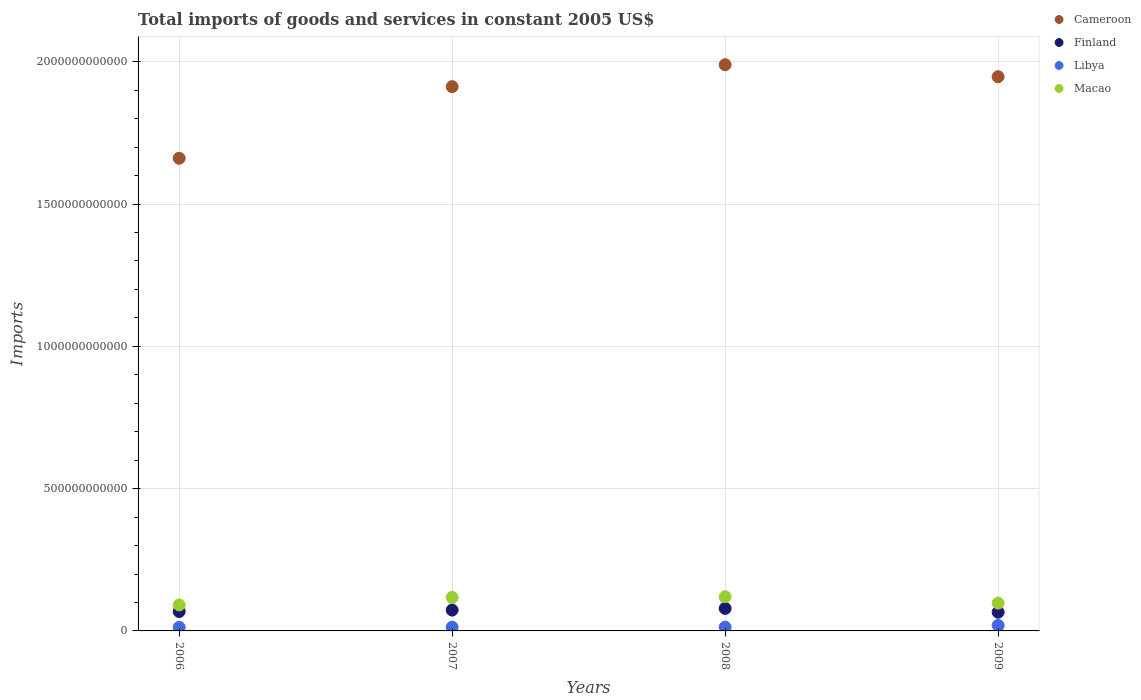What is the total imports of goods and services in Macao in 2008?
Your answer should be very brief. 1.20e+11. Across all years, what is the maximum total imports of goods and services in Libya?
Offer a very short reply. 1.93e+1. Across all years, what is the minimum total imports of goods and services in Macao?
Your answer should be very brief. 9.13e+1. In which year was the total imports of goods and services in Libya minimum?
Your answer should be compact. 2006. What is the total total imports of goods and services in Libya in the graph?
Ensure brevity in your answer.  5.80e+1. What is the difference between the total imports of goods and services in Libya in 2007 and that in 2008?
Give a very brief answer. -7.44e+07. What is the difference between the total imports of goods and services in Cameroon in 2006 and the total imports of goods and services in Finland in 2007?
Provide a short and direct response. 1.59e+12. What is the average total imports of goods and services in Libya per year?
Offer a terse response. 1.45e+1. In the year 2008, what is the difference between the total imports of goods and services in Finland and total imports of goods and services in Macao?
Provide a succinct answer. -4.11e+1. In how many years, is the total imports of goods and services in Finland greater than 800000000000 US$?
Your answer should be compact. 0. What is the ratio of the total imports of goods and services in Macao in 2006 to that in 2007?
Keep it short and to the point. 0.78. Is the total imports of goods and services in Finland in 2006 less than that in 2008?
Make the answer very short. Yes. What is the difference between the highest and the second highest total imports of goods and services in Finland?
Provide a short and direct response. 5.80e+09. What is the difference between the highest and the lowest total imports of goods and services in Libya?
Your response must be concise. 6.82e+09. In how many years, is the total imports of goods and services in Cameroon greater than the average total imports of goods and services in Cameroon taken over all years?
Keep it short and to the point. 3. Is it the case that in every year, the sum of the total imports of goods and services in Macao and total imports of goods and services in Cameroon  is greater than the sum of total imports of goods and services in Finland and total imports of goods and services in Libya?
Make the answer very short. Yes. Is the total imports of goods and services in Finland strictly greater than the total imports of goods and services in Cameroon over the years?
Provide a succinct answer. No. Is the total imports of goods and services in Libya strictly less than the total imports of goods and services in Finland over the years?
Ensure brevity in your answer.  Yes. How many years are there in the graph?
Provide a succinct answer. 4. What is the difference between two consecutive major ticks on the Y-axis?
Provide a short and direct response. 5.00e+11. Are the values on the major ticks of Y-axis written in scientific E-notation?
Your answer should be compact. No. Does the graph contain any zero values?
Make the answer very short. No. Where does the legend appear in the graph?
Your response must be concise. Top right. How many legend labels are there?
Make the answer very short. 4. What is the title of the graph?
Provide a succinct answer. Total imports of goods and services in constant 2005 US$. Does "Djibouti" appear as one of the legend labels in the graph?
Provide a short and direct response. No. What is the label or title of the Y-axis?
Your response must be concise. Imports. What is the Imports in Cameroon in 2006?
Ensure brevity in your answer.  1.66e+12. What is the Imports in Finland in 2006?
Your response must be concise. 6.82e+1. What is the Imports of Libya in 2006?
Your answer should be compact. 1.25e+1. What is the Imports in Macao in 2006?
Keep it short and to the point. 9.13e+1. What is the Imports in Cameroon in 2007?
Provide a succinct answer. 1.91e+12. What is the Imports in Finland in 2007?
Offer a very short reply. 7.32e+1. What is the Imports in Libya in 2007?
Keep it short and to the point. 1.31e+1. What is the Imports in Macao in 2007?
Ensure brevity in your answer.  1.18e+11. What is the Imports in Cameroon in 2008?
Provide a short and direct response. 1.99e+12. What is the Imports in Finland in 2008?
Your answer should be very brief. 7.90e+1. What is the Imports in Libya in 2008?
Provide a short and direct response. 1.32e+1. What is the Imports of Macao in 2008?
Provide a succinct answer. 1.20e+11. What is the Imports of Cameroon in 2009?
Make the answer very short. 1.95e+12. What is the Imports of Finland in 2009?
Give a very brief answer. 6.57e+1. What is the Imports of Libya in 2009?
Keep it short and to the point. 1.93e+1. What is the Imports of Macao in 2009?
Ensure brevity in your answer.  9.76e+1. Across all years, what is the maximum Imports in Cameroon?
Your response must be concise. 1.99e+12. Across all years, what is the maximum Imports in Finland?
Provide a succinct answer. 7.90e+1. Across all years, what is the maximum Imports of Libya?
Keep it short and to the point. 1.93e+1. Across all years, what is the maximum Imports of Macao?
Your response must be concise. 1.20e+11. Across all years, what is the minimum Imports in Cameroon?
Ensure brevity in your answer.  1.66e+12. Across all years, what is the minimum Imports of Finland?
Offer a terse response. 6.57e+1. Across all years, what is the minimum Imports in Libya?
Keep it short and to the point. 1.25e+1. Across all years, what is the minimum Imports of Macao?
Make the answer very short. 9.13e+1. What is the total Imports in Cameroon in the graph?
Provide a short and direct response. 7.51e+12. What is the total Imports in Finland in the graph?
Offer a very short reply. 2.86e+11. What is the total Imports of Libya in the graph?
Make the answer very short. 5.80e+1. What is the total Imports of Macao in the graph?
Offer a very short reply. 4.27e+11. What is the difference between the Imports of Cameroon in 2006 and that in 2007?
Keep it short and to the point. -2.52e+11. What is the difference between the Imports in Finland in 2006 and that in 2007?
Make the answer very short. -5.05e+09. What is the difference between the Imports in Libya in 2006 and that in 2007?
Offer a very short reply. -6.30e+08. What is the difference between the Imports in Macao in 2006 and that in 2007?
Ensure brevity in your answer.  -2.65e+1. What is the difference between the Imports in Cameroon in 2006 and that in 2008?
Keep it short and to the point. -3.29e+11. What is the difference between the Imports in Finland in 2006 and that in 2008?
Provide a short and direct response. -1.09e+1. What is the difference between the Imports in Libya in 2006 and that in 2008?
Make the answer very short. -7.05e+08. What is the difference between the Imports of Macao in 2006 and that in 2008?
Your answer should be compact. -2.89e+1. What is the difference between the Imports in Cameroon in 2006 and that in 2009?
Make the answer very short. -2.87e+11. What is the difference between the Imports of Finland in 2006 and that in 2009?
Your response must be concise. 2.47e+09. What is the difference between the Imports in Libya in 2006 and that in 2009?
Your answer should be compact. -6.82e+09. What is the difference between the Imports in Macao in 2006 and that in 2009?
Your answer should be compact. -6.38e+09. What is the difference between the Imports of Cameroon in 2007 and that in 2008?
Give a very brief answer. -7.72e+1. What is the difference between the Imports of Finland in 2007 and that in 2008?
Your answer should be very brief. -5.80e+09. What is the difference between the Imports of Libya in 2007 and that in 2008?
Your answer should be very brief. -7.44e+07. What is the difference between the Imports of Macao in 2007 and that in 2008?
Ensure brevity in your answer.  -2.39e+09. What is the difference between the Imports in Cameroon in 2007 and that in 2009?
Your answer should be very brief. -3.50e+1. What is the difference between the Imports in Finland in 2007 and that in 2009?
Offer a very short reply. 7.52e+09. What is the difference between the Imports in Libya in 2007 and that in 2009?
Your response must be concise. -6.19e+09. What is the difference between the Imports in Macao in 2007 and that in 2009?
Offer a terse response. 2.01e+1. What is the difference between the Imports in Cameroon in 2008 and that in 2009?
Make the answer very short. 4.22e+1. What is the difference between the Imports of Finland in 2008 and that in 2009?
Keep it short and to the point. 1.33e+1. What is the difference between the Imports in Libya in 2008 and that in 2009?
Keep it short and to the point. -6.12e+09. What is the difference between the Imports of Macao in 2008 and that in 2009?
Give a very brief answer. 2.25e+1. What is the difference between the Imports of Cameroon in 2006 and the Imports of Finland in 2007?
Make the answer very short. 1.59e+12. What is the difference between the Imports of Cameroon in 2006 and the Imports of Libya in 2007?
Your answer should be very brief. 1.65e+12. What is the difference between the Imports of Cameroon in 2006 and the Imports of Macao in 2007?
Your answer should be compact. 1.54e+12. What is the difference between the Imports in Finland in 2006 and the Imports in Libya in 2007?
Your response must be concise. 5.51e+1. What is the difference between the Imports in Finland in 2006 and the Imports in Macao in 2007?
Provide a succinct answer. -4.95e+1. What is the difference between the Imports in Libya in 2006 and the Imports in Macao in 2007?
Ensure brevity in your answer.  -1.05e+11. What is the difference between the Imports of Cameroon in 2006 and the Imports of Finland in 2008?
Your response must be concise. 1.58e+12. What is the difference between the Imports in Cameroon in 2006 and the Imports in Libya in 2008?
Ensure brevity in your answer.  1.65e+12. What is the difference between the Imports in Cameroon in 2006 and the Imports in Macao in 2008?
Give a very brief answer. 1.54e+12. What is the difference between the Imports in Finland in 2006 and the Imports in Libya in 2008?
Your answer should be compact. 5.50e+1. What is the difference between the Imports in Finland in 2006 and the Imports in Macao in 2008?
Your response must be concise. -5.19e+1. What is the difference between the Imports in Libya in 2006 and the Imports in Macao in 2008?
Provide a short and direct response. -1.08e+11. What is the difference between the Imports in Cameroon in 2006 and the Imports in Finland in 2009?
Your answer should be very brief. 1.60e+12. What is the difference between the Imports in Cameroon in 2006 and the Imports in Libya in 2009?
Your answer should be very brief. 1.64e+12. What is the difference between the Imports in Cameroon in 2006 and the Imports in Macao in 2009?
Ensure brevity in your answer.  1.56e+12. What is the difference between the Imports in Finland in 2006 and the Imports in Libya in 2009?
Your response must be concise. 4.89e+1. What is the difference between the Imports in Finland in 2006 and the Imports in Macao in 2009?
Offer a terse response. -2.94e+1. What is the difference between the Imports of Libya in 2006 and the Imports of Macao in 2009?
Ensure brevity in your answer.  -8.52e+1. What is the difference between the Imports in Cameroon in 2007 and the Imports in Finland in 2008?
Ensure brevity in your answer.  1.83e+12. What is the difference between the Imports in Cameroon in 2007 and the Imports in Libya in 2008?
Offer a terse response. 1.90e+12. What is the difference between the Imports of Cameroon in 2007 and the Imports of Macao in 2008?
Ensure brevity in your answer.  1.79e+12. What is the difference between the Imports in Finland in 2007 and the Imports in Libya in 2008?
Ensure brevity in your answer.  6.01e+1. What is the difference between the Imports of Finland in 2007 and the Imports of Macao in 2008?
Your response must be concise. -4.69e+1. What is the difference between the Imports in Libya in 2007 and the Imports in Macao in 2008?
Provide a short and direct response. -1.07e+11. What is the difference between the Imports in Cameroon in 2007 and the Imports in Finland in 2009?
Offer a terse response. 1.85e+12. What is the difference between the Imports in Cameroon in 2007 and the Imports in Libya in 2009?
Your answer should be very brief. 1.89e+12. What is the difference between the Imports in Cameroon in 2007 and the Imports in Macao in 2009?
Give a very brief answer. 1.81e+12. What is the difference between the Imports in Finland in 2007 and the Imports in Libya in 2009?
Give a very brief answer. 5.40e+1. What is the difference between the Imports in Finland in 2007 and the Imports in Macao in 2009?
Keep it short and to the point. -2.44e+1. What is the difference between the Imports of Libya in 2007 and the Imports of Macao in 2009?
Ensure brevity in your answer.  -8.45e+1. What is the difference between the Imports in Cameroon in 2008 and the Imports in Finland in 2009?
Offer a very short reply. 1.92e+12. What is the difference between the Imports of Cameroon in 2008 and the Imports of Libya in 2009?
Offer a very short reply. 1.97e+12. What is the difference between the Imports in Cameroon in 2008 and the Imports in Macao in 2009?
Your answer should be compact. 1.89e+12. What is the difference between the Imports of Finland in 2008 and the Imports of Libya in 2009?
Ensure brevity in your answer.  5.98e+1. What is the difference between the Imports in Finland in 2008 and the Imports in Macao in 2009?
Ensure brevity in your answer.  -1.86e+1. What is the difference between the Imports in Libya in 2008 and the Imports in Macao in 2009?
Keep it short and to the point. -8.45e+1. What is the average Imports in Cameroon per year?
Offer a terse response. 1.88e+12. What is the average Imports in Finland per year?
Your response must be concise. 7.16e+1. What is the average Imports of Libya per year?
Ensure brevity in your answer.  1.45e+1. What is the average Imports of Macao per year?
Provide a succinct answer. 1.07e+11. In the year 2006, what is the difference between the Imports of Cameroon and Imports of Finland?
Provide a succinct answer. 1.59e+12. In the year 2006, what is the difference between the Imports in Cameroon and Imports in Libya?
Your answer should be compact. 1.65e+12. In the year 2006, what is the difference between the Imports in Cameroon and Imports in Macao?
Your response must be concise. 1.57e+12. In the year 2006, what is the difference between the Imports in Finland and Imports in Libya?
Offer a terse response. 5.57e+1. In the year 2006, what is the difference between the Imports of Finland and Imports of Macao?
Keep it short and to the point. -2.31e+1. In the year 2006, what is the difference between the Imports of Libya and Imports of Macao?
Keep it short and to the point. -7.88e+1. In the year 2007, what is the difference between the Imports in Cameroon and Imports in Finland?
Offer a terse response. 1.84e+12. In the year 2007, what is the difference between the Imports of Cameroon and Imports of Libya?
Your answer should be very brief. 1.90e+12. In the year 2007, what is the difference between the Imports of Cameroon and Imports of Macao?
Provide a succinct answer. 1.79e+12. In the year 2007, what is the difference between the Imports of Finland and Imports of Libya?
Give a very brief answer. 6.02e+1. In the year 2007, what is the difference between the Imports in Finland and Imports in Macao?
Your answer should be compact. -4.45e+1. In the year 2007, what is the difference between the Imports of Libya and Imports of Macao?
Ensure brevity in your answer.  -1.05e+11. In the year 2008, what is the difference between the Imports of Cameroon and Imports of Finland?
Your response must be concise. 1.91e+12. In the year 2008, what is the difference between the Imports of Cameroon and Imports of Libya?
Keep it short and to the point. 1.98e+12. In the year 2008, what is the difference between the Imports of Cameroon and Imports of Macao?
Keep it short and to the point. 1.87e+12. In the year 2008, what is the difference between the Imports of Finland and Imports of Libya?
Your answer should be compact. 6.59e+1. In the year 2008, what is the difference between the Imports in Finland and Imports in Macao?
Your response must be concise. -4.11e+1. In the year 2008, what is the difference between the Imports in Libya and Imports in Macao?
Your answer should be compact. -1.07e+11. In the year 2009, what is the difference between the Imports in Cameroon and Imports in Finland?
Provide a succinct answer. 1.88e+12. In the year 2009, what is the difference between the Imports in Cameroon and Imports in Libya?
Your answer should be compact. 1.93e+12. In the year 2009, what is the difference between the Imports in Cameroon and Imports in Macao?
Provide a succinct answer. 1.85e+12. In the year 2009, what is the difference between the Imports in Finland and Imports in Libya?
Give a very brief answer. 4.65e+1. In the year 2009, what is the difference between the Imports in Finland and Imports in Macao?
Your answer should be very brief. -3.19e+1. In the year 2009, what is the difference between the Imports in Libya and Imports in Macao?
Ensure brevity in your answer.  -7.84e+1. What is the ratio of the Imports of Cameroon in 2006 to that in 2007?
Ensure brevity in your answer.  0.87. What is the ratio of the Imports of Finland in 2006 to that in 2007?
Provide a succinct answer. 0.93. What is the ratio of the Imports in Libya in 2006 to that in 2007?
Your response must be concise. 0.95. What is the ratio of the Imports of Macao in 2006 to that in 2007?
Keep it short and to the point. 0.78. What is the ratio of the Imports in Cameroon in 2006 to that in 2008?
Your answer should be compact. 0.83. What is the ratio of the Imports of Finland in 2006 to that in 2008?
Offer a terse response. 0.86. What is the ratio of the Imports in Libya in 2006 to that in 2008?
Offer a very short reply. 0.95. What is the ratio of the Imports of Macao in 2006 to that in 2008?
Your answer should be very brief. 0.76. What is the ratio of the Imports of Cameroon in 2006 to that in 2009?
Ensure brevity in your answer.  0.85. What is the ratio of the Imports of Finland in 2006 to that in 2009?
Offer a very short reply. 1.04. What is the ratio of the Imports in Libya in 2006 to that in 2009?
Your answer should be compact. 0.65. What is the ratio of the Imports of Macao in 2006 to that in 2009?
Offer a very short reply. 0.93. What is the ratio of the Imports in Cameroon in 2007 to that in 2008?
Keep it short and to the point. 0.96. What is the ratio of the Imports in Finland in 2007 to that in 2008?
Keep it short and to the point. 0.93. What is the ratio of the Imports in Macao in 2007 to that in 2008?
Your response must be concise. 0.98. What is the ratio of the Imports in Finland in 2007 to that in 2009?
Provide a short and direct response. 1.11. What is the ratio of the Imports in Libya in 2007 to that in 2009?
Keep it short and to the point. 0.68. What is the ratio of the Imports of Macao in 2007 to that in 2009?
Ensure brevity in your answer.  1.21. What is the ratio of the Imports in Cameroon in 2008 to that in 2009?
Give a very brief answer. 1.02. What is the ratio of the Imports in Finland in 2008 to that in 2009?
Make the answer very short. 1.2. What is the ratio of the Imports of Libya in 2008 to that in 2009?
Give a very brief answer. 0.68. What is the ratio of the Imports of Macao in 2008 to that in 2009?
Your response must be concise. 1.23. What is the difference between the highest and the second highest Imports in Cameroon?
Offer a very short reply. 4.22e+1. What is the difference between the highest and the second highest Imports of Finland?
Your answer should be very brief. 5.80e+09. What is the difference between the highest and the second highest Imports in Libya?
Provide a succinct answer. 6.12e+09. What is the difference between the highest and the second highest Imports of Macao?
Provide a short and direct response. 2.39e+09. What is the difference between the highest and the lowest Imports of Cameroon?
Your answer should be compact. 3.29e+11. What is the difference between the highest and the lowest Imports of Finland?
Offer a very short reply. 1.33e+1. What is the difference between the highest and the lowest Imports of Libya?
Provide a succinct answer. 6.82e+09. What is the difference between the highest and the lowest Imports in Macao?
Give a very brief answer. 2.89e+1. 